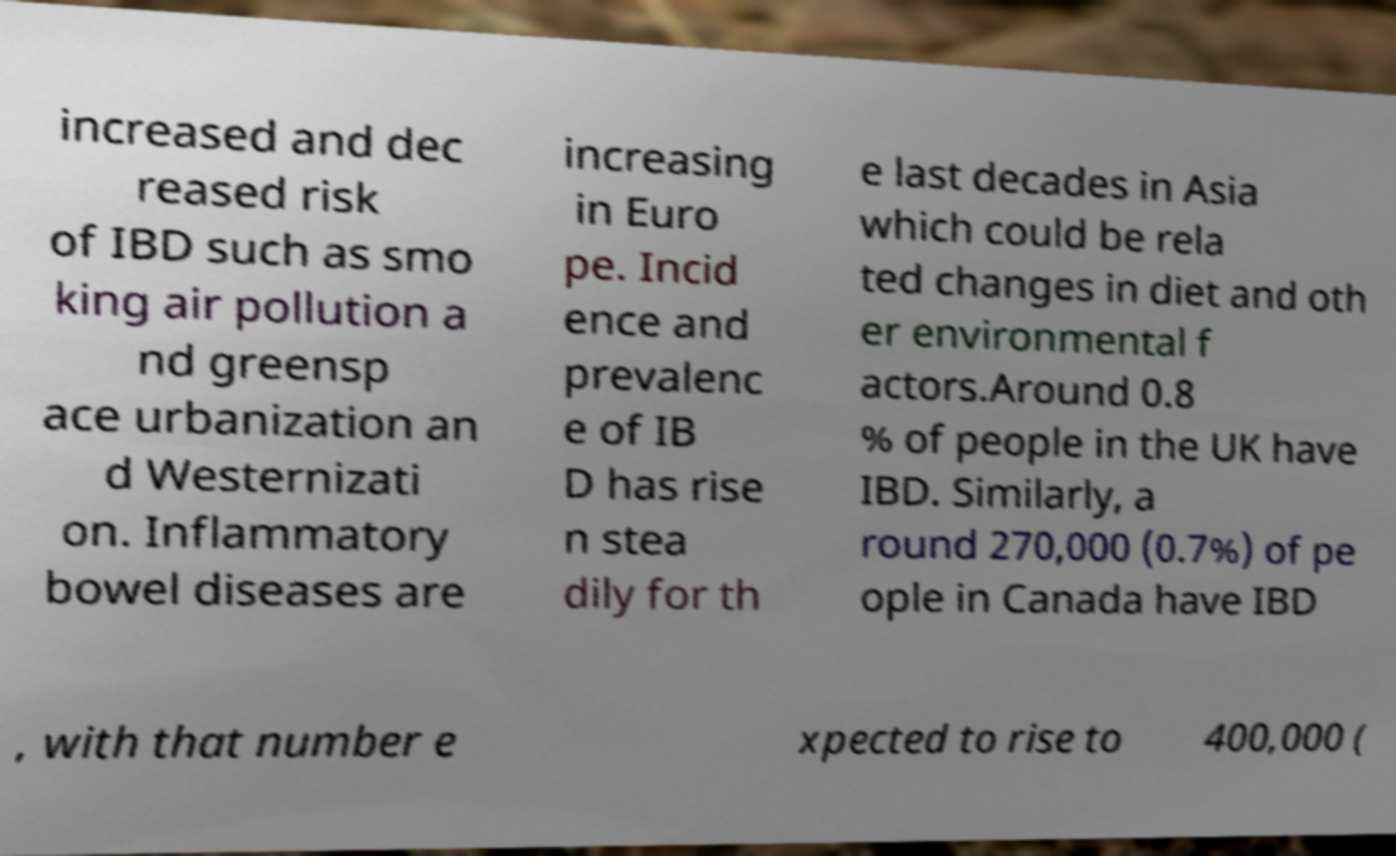Please read and relay the text visible in this image. What does it say? increased and dec reased risk of IBD such as smo king air pollution a nd greensp ace urbanization an d Westernizati on. Inflammatory bowel diseases are increasing in Euro pe. Incid ence and prevalenc e of IB D has rise n stea dily for th e last decades in Asia which could be rela ted changes in diet and oth er environmental f actors.Around 0.8 % of people in the UK have IBD. Similarly, a round 270,000 (0.7%) of pe ople in Canada have IBD , with that number e xpected to rise to 400,000 ( 